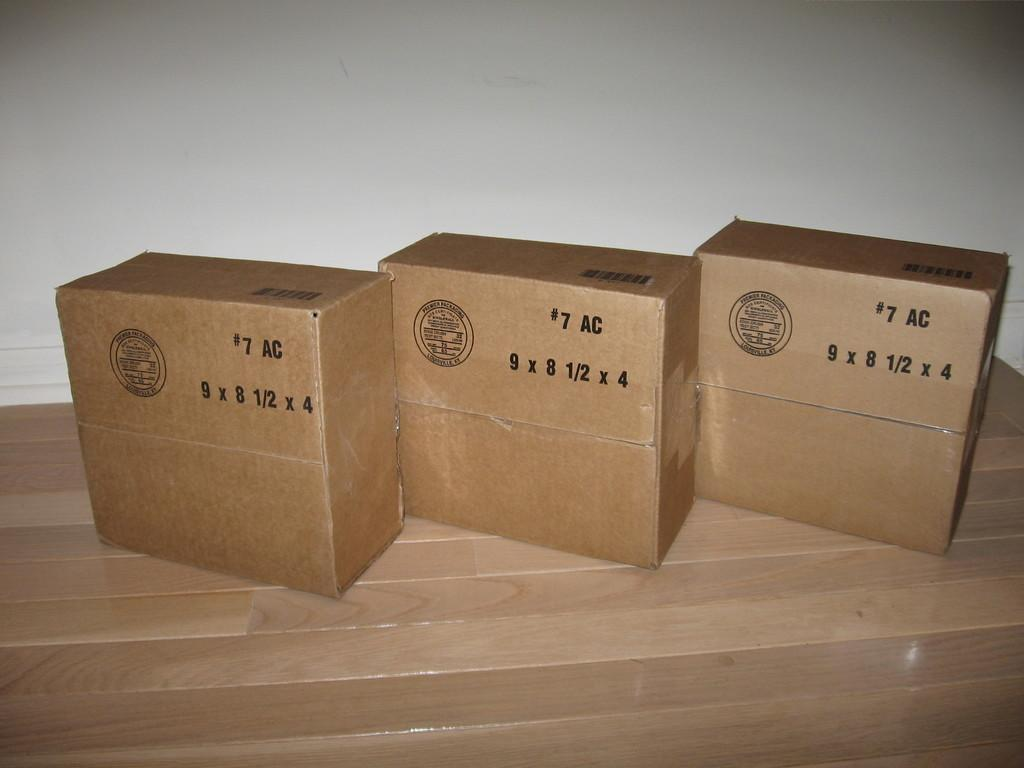<image>
Give a short and clear explanation of the subsequent image. Three boxes made by Premier Packaging in Louisville, KY 